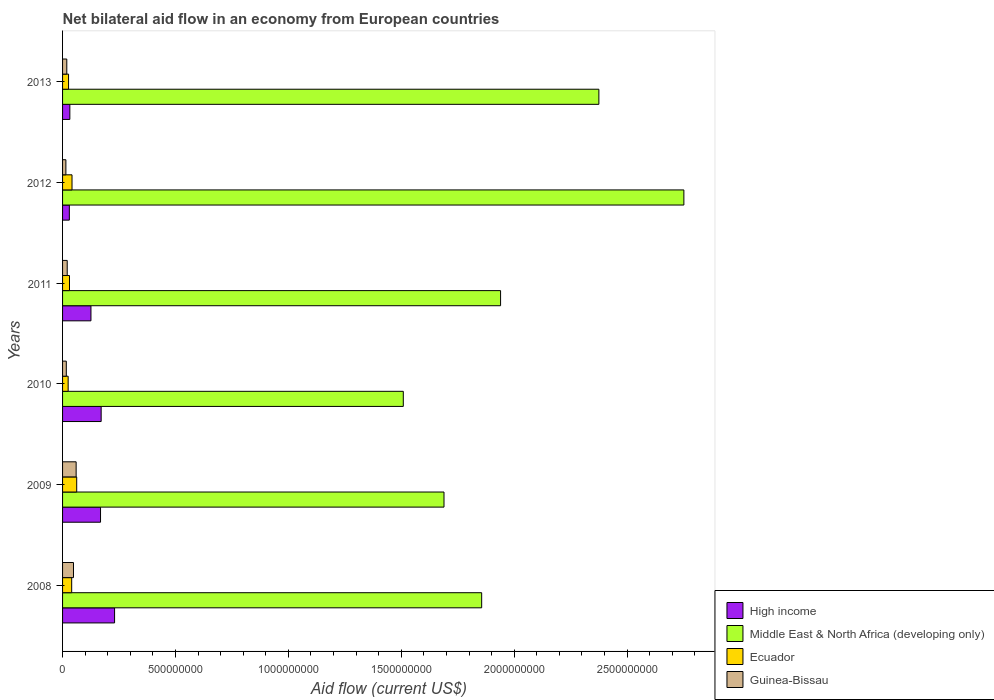How many different coloured bars are there?
Make the answer very short. 4. How many groups of bars are there?
Provide a short and direct response. 6. Are the number of bars per tick equal to the number of legend labels?
Give a very brief answer. Yes. How many bars are there on the 6th tick from the top?
Ensure brevity in your answer.  4. What is the label of the 1st group of bars from the top?
Give a very brief answer. 2013. What is the net bilateral aid flow in Middle East & North Africa (developing only) in 2012?
Provide a short and direct response. 2.75e+09. Across all years, what is the maximum net bilateral aid flow in Guinea-Bissau?
Keep it short and to the point. 6.01e+07. Across all years, what is the minimum net bilateral aid flow in Guinea-Bissau?
Your response must be concise. 1.47e+07. In which year was the net bilateral aid flow in Middle East & North Africa (developing only) minimum?
Offer a very short reply. 2010. What is the total net bilateral aid flow in Middle East & North Africa (developing only) in the graph?
Keep it short and to the point. 1.21e+1. What is the difference between the net bilateral aid flow in High income in 2010 and that in 2012?
Provide a short and direct response. 1.41e+08. What is the difference between the net bilateral aid flow in Middle East & North Africa (developing only) in 2010 and the net bilateral aid flow in High income in 2013?
Make the answer very short. 1.48e+09. What is the average net bilateral aid flow in Middle East & North Africa (developing only) per year?
Provide a succinct answer. 2.02e+09. In the year 2012, what is the difference between the net bilateral aid flow in High income and net bilateral aid flow in Ecuador?
Your response must be concise. -1.19e+07. What is the ratio of the net bilateral aid flow in Guinea-Bissau in 2008 to that in 2009?
Offer a very short reply. 0.8. Is the difference between the net bilateral aid flow in High income in 2011 and 2012 greater than the difference between the net bilateral aid flow in Ecuador in 2011 and 2012?
Ensure brevity in your answer.  Yes. What is the difference between the highest and the second highest net bilateral aid flow in High income?
Your response must be concise. 5.94e+07. What is the difference between the highest and the lowest net bilateral aid flow in Ecuador?
Keep it short and to the point. 3.79e+07. Is it the case that in every year, the sum of the net bilateral aid flow in High income and net bilateral aid flow in Middle East & North Africa (developing only) is greater than the sum of net bilateral aid flow in Ecuador and net bilateral aid flow in Guinea-Bissau?
Ensure brevity in your answer.  Yes. What does the 3rd bar from the top in 2009 represents?
Provide a short and direct response. Middle East & North Africa (developing only). What does the 1st bar from the bottom in 2012 represents?
Give a very brief answer. High income. Is it the case that in every year, the sum of the net bilateral aid flow in Guinea-Bissau and net bilateral aid flow in Middle East & North Africa (developing only) is greater than the net bilateral aid flow in High income?
Make the answer very short. Yes. How many bars are there?
Your answer should be compact. 24. Are the values on the major ticks of X-axis written in scientific E-notation?
Ensure brevity in your answer.  No. How many legend labels are there?
Provide a succinct answer. 4. What is the title of the graph?
Ensure brevity in your answer.  Net bilateral aid flow in an economy from European countries. Does "Syrian Arab Republic" appear as one of the legend labels in the graph?
Your answer should be compact. No. What is the label or title of the X-axis?
Your response must be concise. Aid flow (current US$). What is the Aid flow (current US$) in High income in 2008?
Offer a terse response. 2.30e+08. What is the Aid flow (current US$) of Middle East & North Africa (developing only) in 2008?
Your response must be concise. 1.86e+09. What is the Aid flow (current US$) of Ecuador in 2008?
Your answer should be very brief. 4.04e+07. What is the Aid flow (current US$) of Guinea-Bissau in 2008?
Ensure brevity in your answer.  4.84e+07. What is the Aid flow (current US$) of High income in 2009?
Offer a terse response. 1.68e+08. What is the Aid flow (current US$) of Middle East & North Africa (developing only) in 2009?
Offer a very short reply. 1.69e+09. What is the Aid flow (current US$) of Ecuador in 2009?
Offer a terse response. 6.26e+07. What is the Aid flow (current US$) in Guinea-Bissau in 2009?
Make the answer very short. 6.01e+07. What is the Aid flow (current US$) in High income in 2010?
Ensure brevity in your answer.  1.71e+08. What is the Aid flow (current US$) in Middle East & North Africa (developing only) in 2010?
Keep it short and to the point. 1.51e+09. What is the Aid flow (current US$) of Ecuador in 2010?
Provide a short and direct response. 2.47e+07. What is the Aid flow (current US$) in Guinea-Bissau in 2010?
Provide a succinct answer. 1.66e+07. What is the Aid flow (current US$) of High income in 2011?
Your answer should be compact. 1.26e+08. What is the Aid flow (current US$) in Middle East & North Africa (developing only) in 2011?
Provide a short and direct response. 1.94e+09. What is the Aid flow (current US$) in Ecuador in 2011?
Give a very brief answer. 3.07e+07. What is the Aid flow (current US$) of Guinea-Bissau in 2011?
Provide a short and direct response. 2.06e+07. What is the Aid flow (current US$) in High income in 2012?
Your response must be concise. 3.00e+07. What is the Aid flow (current US$) of Middle East & North Africa (developing only) in 2012?
Offer a very short reply. 2.75e+09. What is the Aid flow (current US$) of Ecuador in 2012?
Your answer should be very brief. 4.19e+07. What is the Aid flow (current US$) of Guinea-Bissau in 2012?
Your answer should be very brief. 1.47e+07. What is the Aid flow (current US$) in High income in 2013?
Ensure brevity in your answer.  3.22e+07. What is the Aid flow (current US$) in Middle East & North Africa (developing only) in 2013?
Your answer should be compact. 2.38e+09. What is the Aid flow (current US$) of Ecuador in 2013?
Your answer should be compact. 2.66e+07. What is the Aid flow (current US$) in Guinea-Bissau in 2013?
Your answer should be compact. 1.88e+07. Across all years, what is the maximum Aid flow (current US$) in High income?
Your answer should be compact. 2.30e+08. Across all years, what is the maximum Aid flow (current US$) of Middle East & North Africa (developing only)?
Ensure brevity in your answer.  2.75e+09. Across all years, what is the maximum Aid flow (current US$) of Ecuador?
Make the answer very short. 6.26e+07. Across all years, what is the maximum Aid flow (current US$) of Guinea-Bissau?
Offer a very short reply. 6.01e+07. Across all years, what is the minimum Aid flow (current US$) in High income?
Your answer should be compact. 3.00e+07. Across all years, what is the minimum Aid flow (current US$) in Middle East & North Africa (developing only)?
Your answer should be compact. 1.51e+09. Across all years, what is the minimum Aid flow (current US$) in Ecuador?
Provide a succinct answer. 2.47e+07. Across all years, what is the minimum Aid flow (current US$) in Guinea-Bissau?
Provide a short and direct response. 1.47e+07. What is the total Aid flow (current US$) of High income in the graph?
Provide a short and direct response. 7.57e+08. What is the total Aid flow (current US$) in Middle East & North Africa (developing only) in the graph?
Make the answer very short. 1.21e+1. What is the total Aid flow (current US$) in Ecuador in the graph?
Provide a succinct answer. 2.27e+08. What is the total Aid flow (current US$) in Guinea-Bissau in the graph?
Ensure brevity in your answer.  1.79e+08. What is the difference between the Aid flow (current US$) in High income in 2008 and that in 2009?
Provide a succinct answer. 6.22e+07. What is the difference between the Aid flow (current US$) in Middle East & North Africa (developing only) in 2008 and that in 2009?
Give a very brief answer. 1.67e+08. What is the difference between the Aid flow (current US$) of Ecuador in 2008 and that in 2009?
Give a very brief answer. -2.22e+07. What is the difference between the Aid flow (current US$) in Guinea-Bissau in 2008 and that in 2009?
Keep it short and to the point. -1.18e+07. What is the difference between the Aid flow (current US$) of High income in 2008 and that in 2010?
Make the answer very short. 5.94e+07. What is the difference between the Aid flow (current US$) in Middle East & North Africa (developing only) in 2008 and that in 2010?
Keep it short and to the point. 3.47e+08. What is the difference between the Aid flow (current US$) of Ecuador in 2008 and that in 2010?
Make the answer very short. 1.57e+07. What is the difference between the Aid flow (current US$) of Guinea-Bissau in 2008 and that in 2010?
Make the answer very short. 3.18e+07. What is the difference between the Aid flow (current US$) of High income in 2008 and that in 2011?
Provide a succinct answer. 1.05e+08. What is the difference between the Aid flow (current US$) of Middle East & North Africa (developing only) in 2008 and that in 2011?
Ensure brevity in your answer.  -8.38e+07. What is the difference between the Aid flow (current US$) in Ecuador in 2008 and that in 2011?
Ensure brevity in your answer.  9.73e+06. What is the difference between the Aid flow (current US$) of Guinea-Bissau in 2008 and that in 2011?
Make the answer very short. 2.78e+07. What is the difference between the Aid flow (current US$) of High income in 2008 and that in 2012?
Your answer should be compact. 2.00e+08. What is the difference between the Aid flow (current US$) of Middle East & North Africa (developing only) in 2008 and that in 2012?
Your answer should be very brief. -8.96e+08. What is the difference between the Aid flow (current US$) in Ecuador in 2008 and that in 2012?
Keep it short and to the point. -1.46e+06. What is the difference between the Aid flow (current US$) in Guinea-Bissau in 2008 and that in 2012?
Ensure brevity in your answer.  3.36e+07. What is the difference between the Aid flow (current US$) of High income in 2008 and that in 2013?
Ensure brevity in your answer.  1.98e+08. What is the difference between the Aid flow (current US$) in Middle East & North Africa (developing only) in 2008 and that in 2013?
Keep it short and to the point. -5.19e+08. What is the difference between the Aid flow (current US$) in Ecuador in 2008 and that in 2013?
Provide a short and direct response. 1.38e+07. What is the difference between the Aid flow (current US$) in Guinea-Bissau in 2008 and that in 2013?
Ensure brevity in your answer.  2.96e+07. What is the difference between the Aid flow (current US$) of High income in 2009 and that in 2010?
Your answer should be compact. -2.81e+06. What is the difference between the Aid flow (current US$) in Middle East & North Africa (developing only) in 2009 and that in 2010?
Your response must be concise. 1.80e+08. What is the difference between the Aid flow (current US$) of Ecuador in 2009 and that in 2010?
Give a very brief answer. 3.79e+07. What is the difference between the Aid flow (current US$) in Guinea-Bissau in 2009 and that in 2010?
Offer a terse response. 4.36e+07. What is the difference between the Aid flow (current US$) in High income in 2009 and that in 2011?
Keep it short and to the point. 4.24e+07. What is the difference between the Aid flow (current US$) of Middle East & North Africa (developing only) in 2009 and that in 2011?
Your answer should be compact. -2.51e+08. What is the difference between the Aid flow (current US$) in Ecuador in 2009 and that in 2011?
Your answer should be very brief. 3.20e+07. What is the difference between the Aid flow (current US$) of Guinea-Bissau in 2009 and that in 2011?
Offer a very short reply. 3.95e+07. What is the difference between the Aid flow (current US$) in High income in 2009 and that in 2012?
Make the answer very short. 1.38e+08. What is the difference between the Aid flow (current US$) of Middle East & North Africa (developing only) in 2009 and that in 2012?
Provide a short and direct response. -1.06e+09. What is the difference between the Aid flow (current US$) in Ecuador in 2009 and that in 2012?
Your answer should be very brief. 2.08e+07. What is the difference between the Aid flow (current US$) in Guinea-Bissau in 2009 and that in 2012?
Your answer should be compact. 4.54e+07. What is the difference between the Aid flow (current US$) of High income in 2009 and that in 2013?
Make the answer very short. 1.36e+08. What is the difference between the Aid flow (current US$) in Middle East & North Africa (developing only) in 2009 and that in 2013?
Give a very brief answer. -6.86e+08. What is the difference between the Aid flow (current US$) in Ecuador in 2009 and that in 2013?
Give a very brief answer. 3.60e+07. What is the difference between the Aid flow (current US$) of Guinea-Bissau in 2009 and that in 2013?
Your response must be concise. 4.14e+07. What is the difference between the Aid flow (current US$) of High income in 2010 and that in 2011?
Provide a short and direct response. 4.52e+07. What is the difference between the Aid flow (current US$) in Middle East & North Africa (developing only) in 2010 and that in 2011?
Your response must be concise. -4.31e+08. What is the difference between the Aid flow (current US$) of Ecuador in 2010 and that in 2011?
Provide a succinct answer. -5.94e+06. What is the difference between the Aid flow (current US$) of Guinea-Bissau in 2010 and that in 2011?
Give a very brief answer. -4.01e+06. What is the difference between the Aid flow (current US$) of High income in 2010 and that in 2012?
Keep it short and to the point. 1.41e+08. What is the difference between the Aid flow (current US$) of Middle East & North Africa (developing only) in 2010 and that in 2012?
Give a very brief answer. -1.24e+09. What is the difference between the Aid flow (current US$) of Ecuador in 2010 and that in 2012?
Make the answer very short. -1.71e+07. What is the difference between the Aid flow (current US$) in Guinea-Bissau in 2010 and that in 2012?
Give a very brief answer. 1.83e+06. What is the difference between the Aid flow (current US$) of High income in 2010 and that in 2013?
Ensure brevity in your answer.  1.39e+08. What is the difference between the Aid flow (current US$) of Middle East & North Africa (developing only) in 2010 and that in 2013?
Offer a very short reply. -8.66e+08. What is the difference between the Aid flow (current US$) of Ecuador in 2010 and that in 2013?
Offer a terse response. -1.85e+06. What is the difference between the Aid flow (current US$) of Guinea-Bissau in 2010 and that in 2013?
Your answer should be very brief. -2.18e+06. What is the difference between the Aid flow (current US$) in High income in 2011 and that in 2012?
Give a very brief answer. 9.57e+07. What is the difference between the Aid flow (current US$) in Middle East & North Africa (developing only) in 2011 and that in 2012?
Ensure brevity in your answer.  -8.12e+08. What is the difference between the Aid flow (current US$) of Ecuador in 2011 and that in 2012?
Your answer should be very brief. -1.12e+07. What is the difference between the Aid flow (current US$) of Guinea-Bissau in 2011 and that in 2012?
Provide a short and direct response. 5.84e+06. What is the difference between the Aid flow (current US$) of High income in 2011 and that in 2013?
Your answer should be compact. 9.34e+07. What is the difference between the Aid flow (current US$) in Middle East & North Africa (developing only) in 2011 and that in 2013?
Offer a very short reply. -4.35e+08. What is the difference between the Aid flow (current US$) of Ecuador in 2011 and that in 2013?
Give a very brief answer. 4.09e+06. What is the difference between the Aid flow (current US$) of Guinea-Bissau in 2011 and that in 2013?
Offer a terse response. 1.83e+06. What is the difference between the Aid flow (current US$) of High income in 2012 and that in 2013?
Provide a succinct answer. -2.25e+06. What is the difference between the Aid flow (current US$) in Middle East & North Africa (developing only) in 2012 and that in 2013?
Provide a succinct answer. 3.76e+08. What is the difference between the Aid flow (current US$) of Ecuador in 2012 and that in 2013?
Your answer should be compact. 1.53e+07. What is the difference between the Aid flow (current US$) in Guinea-Bissau in 2012 and that in 2013?
Your answer should be very brief. -4.01e+06. What is the difference between the Aid flow (current US$) in High income in 2008 and the Aid flow (current US$) in Middle East & North Africa (developing only) in 2009?
Your answer should be very brief. -1.46e+09. What is the difference between the Aid flow (current US$) of High income in 2008 and the Aid flow (current US$) of Ecuador in 2009?
Ensure brevity in your answer.  1.68e+08. What is the difference between the Aid flow (current US$) in High income in 2008 and the Aid flow (current US$) in Guinea-Bissau in 2009?
Keep it short and to the point. 1.70e+08. What is the difference between the Aid flow (current US$) of Middle East & North Africa (developing only) in 2008 and the Aid flow (current US$) of Ecuador in 2009?
Your response must be concise. 1.79e+09. What is the difference between the Aid flow (current US$) in Middle East & North Africa (developing only) in 2008 and the Aid flow (current US$) in Guinea-Bissau in 2009?
Provide a succinct answer. 1.80e+09. What is the difference between the Aid flow (current US$) in Ecuador in 2008 and the Aid flow (current US$) in Guinea-Bissau in 2009?
Provide a succinct answer. -1.97e+07. What is the difference between the Aid flow (current US$) in High income in 2008 and the Aid flow (current US$) in Middle East & North Africa (developing only) in 2010?
Your answer should be compact. -1.28e+09. What is the difference between the Aid flow (current US$) in High income in 2008 and the Aid flow (current US$) in Ecuador in 2010?
Provide a short and direct response. 2.06e+08. What is the difference between the Aid flow (current US$) in High income in 2008 and the Aid flow (current US$) in Guinea-Bissau in 2010?
Offer a very short reply. 2.14e+08. What is the difference between the Aid flow (current US$) in Middle East & North Africa (developing only) in 2008 and the Aid flow (current US$) in Ecuador in 2010?
Provide a short and direct response. 1.83e+09. What is the difference between the Aid flow (current US$) of Middle East & North Africa (developing only) in 2008 and the Aid flow (current US$) of Guinea-Bissau in 2010?
Ensure brevity in your answer.  1.84e+09. What is the difference between the Aid flow (current US$) of Ecuador in 2008 and the Aid flow (current US$) of Guinea-Bissau in 2010?
Your answer should be compact. 2.38e+07. What is the difference between the Aid flow (current US$) in High income in 2008 and the Aid flow (current US$) in Middle East & North Africa (developing only) in 2011?
Keep it short and to the point. -1.71e+09. What is the difference between the Aid flow (current US$) in High income in 2008 and the Aid flow (current US$) in Ecuador in 2011?
Offer a very short reply. 2.00e+08. What is the difference between the Aid flow (current US$) of High income in 2008 and the Aid flow (current US$) of Guinea-Bissau in 2011?
Give a very brief answer. 2.10e+08. What is the difference between the Aid flow (current US$) in Middle East & North Africa (developing only) in 2008 and the Aid flow (current US$) in Ecuador in 2011?
Keep it short and to the point. 1.83e+09. What is the difference between the Aid flow (current US$) of Middle East & North Africa (developing only) in 2008 and the Aid flow (current US$) of Guinea-Bissau in 2011?
Your answer should be very brief. 1.84e+09. What is the difference between the Aid flow (current US$) in Ecuador in 2008 and the Aid flow (current US$) in Guinea-Bissau in 2011?
Your answer should be very brief. 1.98e+07. What is the difference between the Aid flow (current US$) of High income in 2008 and the Aid flow (current US$) of Middle East & North Africa (developing only) in 2012?
Ensure brevity in your answer.  -2.52e+09. What is the difference between the Aid flow (current US$) in High income in 2008 and the Aid flow (current US$) in Ecuador in 2012?
Offer a very short reply. 1.88e+08. What is the difference between the Aid flow (current US$) in High income in 2008 and the Aid flow (current US$) in Guinea-Bissau in 2012?
Your response must be concise. 2.16e+08. What is the difference between the Aid flow (current US$) in Middle East & North Africa (developing only) in 2008 and the Aid flow (current US$) in Ecuador in 2012?
Give a very brief answer. 1.81e+09. What is the difference between the Aid flow (current US$) of Middle East & North Africa (developing only) in 2008 and the Aid flow (current US$) of Guinea-Bissau in 2012?
Ensure brevity in your answer.  1.84e+09. What is the difference between the Aid flow (current US$) of Ecuador in 2008 and the Aid flow (current US$) of Guinea-Bissau in 2012?
Give a very brief answer. 2.57e+07. What is the difference between the Aid flow (current US$) in High income in 2008 and the Aid flow (current US$) in Middle East & North Africa (developing only) in 2013?
Offer a very short reply. -2.14e+09. What is the difference between the Aid flow (current US$) of High income in 2008 and the Aid flow (current US$) of Ecuador in 2013?
Your answer should be very brief. 2.04e+08. What is the difference between the Aid flow (current US$) in High income in 2008 and the Aid flow (current US$) in Guinea-Bissau in 2013?
Ensure brevity in your answer.  2.12e+08. What is the difference between the Aid flow (current US$) of Middle East & North Africa (developing only) in 2008 and the Aid flow (current US$) of Ecuador in 2013?
Offer a very short reply. 1.83e+09. What is the difference between the Aid flow (current US$) of Middle East & North Africa (developing only) in 2008 and the Aid flow (current US$) of Guinea-Bissau in 2013?
Give a very brief answer. 1.84e+09. What is the difference between the Aid flow (current US$) of Ecuador in 2008 and the Aid flow (current US$) of Guinea-Bissau in 2013?
Ensure brevity in your answer.  2.17e+07. What is the difference between the Aid flow (current US$) of High income in 2009 and the Aid flow (current US$) of Middle East & North Africa (developing only) in 2010?
Your answer should be very brief. -1.34e+09. What is the difference between the Aid flow (current US$) of High income in 2009 and the Aid flow (current US$) of Ecuador in 2010?
Your response must be concise. 1.43e+08. What is the difference between the Aid flow (current US$) of High income in 2009 and the Aid flow (current US$) of Guinea-Bissau in 2010?
Provide a succinct answer. 1.52e+08. What is the difference between the Aid flow (current US$) of Middle East & North Africa (developing only) in 2009 and the Aid flow (current US$) of Ecuador in 2010?
Your response must be concise. 1.66e+09. What is the difference between the Aid flow (current US$) of Middle East & North Africa (developing only) in 2009 and the Aid flow (current US$) of Guinea-Bissau in 2010?
Your answer should be very brief. 1.67e+09. What is the difference between the Aid flow (current US$) of Ecuador in 2009 and the Aid flow (current US$) of Guinea-Bissau in 2010?
Your response must be concise. 4.61e+07. What is the difference between the Aid flow (current US$) of High income in 2009 and the Aid flow (current US$) of Middle East & North Africa (developing only) in 2011?
Provide a succinct answer. -1.77e+09. What is the difference between the Aid flow (current US$) of High income in 2009 and the Aid flow (current US$) of Ecuador in 2011?
Offer a very short reply. 1.37e+08. What is the difference between the Aid flow (current US$) in High income in 2009 and the Aid flow (current US$) in Guinea-Bissau in 2011?
Provide a succinct answer. 1.48e+08. What is the difference between the Aid flow (current US$) in Middle East & North Africa (developing only) in 2009 and the Aid flow (current US$) in Ecuador in 2011?
Offer a terse response. 1.66e+09. What is the difference between the Aid flow (current US$) in Middle East & North Africa (developing only) in 2009 and the Aid flow (current US$) in Guinea-Bissau in 2011?
Provide a short and direct response. 1.67e+09. What is the difference between the Aid flow (current US$) in Ecuador in 2009 and the Aid flow (current US$) in Guinea-Bissau in 2011?
Your answer should be compact. 4.20e+07. What is the difference between the Aid flow (current US$) in High income in 2009 and the Aid flow (current US$) in Middle East & North Africa (developing only) in 2012?
Ensure brevity in your answer.  -2.58e+09. What is the difference between the Aid flow (current US$) of High income in 2009 and the Aid flow (current US$) of Ecuador in 2012?
Your answer should be compact. 1.26e+08. What is the difference between the Aid flow (current US$) in High income in 2009 and the Aid flow (current US$) in Guinea-Bissau in 2012?
Provide a succinct answer. 1.53e+08. What is the difference between the Aid flow (current US$) of Middle East & North Africa (developing only) in 2009 and the Aid flow (current US$) of Ecuador in 2012?
Your answer should be very brief. 1.65e+09. What is the difference between the Aid flow (current US$) of Middle East & North Africa (developing only) in 2009 and the Aid flow (current US$) of Guinea-Bissau in 2012?
Give a very brief answer. 1.67e+09. What is the difference between the Aid flow (current US$) of Ecuador in 2009 and the Aid flow (current US$) of Guinea-Bissau in 2012?
Make the answer very short. 4.79e+07. What is the difference between the Aid flow (current US$) of High income in 2009 and the Aid flow (current US$) of Middle East & North Africa (developing only) in 2013?
Keep it short and to the point. -2.21e+09. What is the difference between the Aid flow (current US$) of High income in 2009 and the Aid flow (current US$) of Ecuador in 2013?
Your answer should be very brief. 1.42e+08. What is the difference between the Aid flow (current US$) of High income in 2009 and the Aid flow (current US$) of Guinea-Bissau in 2013?
Offer a very short reply. 1.49e+08. What is the difference between the Aid flow (current US$) in Middle East & North Africa (developing only) in 2009 and the Aid flow (current US$) in Ecuador in 2013?
Ensure brevity in your answer.  1.66e+09. What is the difference between the Aid flow (current US$) of Middle East & North Africa (developing only) in 2009 and the Aid flow (current US$) of Guinea-Bissau in 2013?
Provide a succinct answer. 1.67e+09. What is the difference between the Aid flow (current US$) of Ecuador in 2009 and the Aid flow (current US$) of Guinea-Bissau in 2013?
Make the answer very short. 4.39e+07. What is the difference between the Aid flow (current US$) of High income in 2010 and the Aid flow (current US$) of Middle East & North Africa (developing only) in 2011?
Your answer should be very brief. -1.77e+09. What is the difference between the Aid flow (current US$) in High income in 2010 and the Aid flow (current US$) in Ecuador in 2011?
Offer a very short reply. 1.40e+08. What is the difference between the Aid flow (current US$) in High income in 2010 and the Aid flow (current US$) in Guinea-Bissau in 2011?
Provide a succinct answer. 1.50e+08. What is the difference between the Aid flow (current US$) in Middle East & North Africa (developing only) in 2010 and the Aid flow (current US$) in Ecuador in 2011?
Your response must be concise. 1.48e+09. What is the difference between the Aid flow (current US$) in Middle East & North Africa (developing only) in 2010 and the Aid flow (current US$) in Guinea-Bissau in 2011?
Your answer should be very brief. 1.49e+09. What is the difference between the Aid flow (current US$) of Ecuador in 2010 and the Aid flow (current US$) of Guinea-Bissau in 2011?
Offer a very short reply. 4.16e+06. What is the difference between the Aid flow (current US$) of High income in 2010 and the Aid flow (current US$) of Middle East & North Africa (developing only) in 2012?
Your answer should be compact. -2.58e+09. What is the difference between the Aid flow (current US$) of High income in 2010 and the Aid flow (current US$) of Ecuador in 2012?
Ensure brevity in your answer.  1.29e+08. What is the difference between the Aid flow (current US$) of High income in 2010 and the Aid flow (current US$) of Guinea-Bissau in 2012?
Provide a succinct answer. 1.56e+08. What is the difference between the Aid flow (current US$) of Middle East & North Africa (developing only) in 2010 and the Aid flow (current US$) of Ecuador in 2012?
Provide a succinct answer. 1.47e+09. What is the difference between the Aid flow (current US$) in Middle East & North Africa (developing only) in 2010 and the Aid flow (current US$) in Guinea-Bissau in 2012?
Your answer should be very brief. 1.49e+09. What is the difference between the Aid flow (current US$) in High income in 2010 and the Aid flow (current US$) in Middle East & North Africa (developing only) in 2013?
Your response must be concise. -2.20e+09. What is the difference between the Aid flow (current US$) in High income in 2010 and the Aid flow (current US$) in Ecuador in 2013?
Provide a short and direct response. 1.44e+08. What is the difference between the Aid flow (current US$) in High income in 2010 and the Aid flow (current US$) in Guinea-Bissau in 2013?
Give a very brief answer. 1.52e+08. What is the difference between the Aid flow (current US$) in Middle East & North Africa (developing only) in 2010 and the Aid flow (current US$) in Ecuador in 2013?
Provide a short and direct response. 1.48e+09. What is the difference between the Aid flow (current US$) in Middle East & North Africa (developing only) in 2010 and the Aid flow (current US$) in Guinea-Bissau in 2013?
Offer a terse response. 1.49e+09. What is the difference between the Aid flow (current US$) in Ecuador in 2010 and the Aid flow (current US$) in Guinea-Bissau in 2013?
Your response must be concise. 5.99e+06. What is the difference between the Aid flow (current US$) of High income in 2011 and the Aid flow (current US$) of Middle East & North Africa (developing only) in 2012?
Your answer should be compact. -2.63e+09. What is the difference between the Aid flow (current US$) in High income in 2011 and the Aid flow (current US$) in Ecuador in 2012?
Ensure brevity in your answer.  8.38e+07. What is the difference between the Aid flow (current US$) of High income in 2011 and the Aid flow (current US$) of Guinea-Bissau in 2012?
Keep it short and to the point. 1.11e+08. What is the difference between the Aid flow (current US$) in Middle East & North Africa (developing only) in 2011 and the Aid flow (current US$) in Ecuador in 2012?
Your response must be concise. 1.90e+09. What is the difference between the Aid flow (current US$) of Middle East & North Africa (developing only) in 2011 and the Aid flow (current US$) of Guinea-Bissau in 2012?
Provide a succinct answer. 1.93e+09. What is the difference between the Aid flow (current US$) of Ecuador in 2011 and the Aid flow (current US$) of Guinea-Bissau in 2012?
Provide a short and direct response. 1.59e+07. What is the difference between the Aid flow (current US$) of High income in 2011 and the Aid flow (current US$) of Middle East & North Africa (developing only) in 2013?
Your answer should be compact. -2.25e+09. What is the difference between the Aid flow (current US$) in High income in 2011 and the Aid flow (current US$) in Ecuador in 2013?
Make the answer very short. 9.91e+07. What is the difference between the Aid flow (current US$) in High income in 2011 and the Aid flow (current US$) in Guinea-Bissau in 2013?
Your answer should be compact. 1.07e+08. What is the difference between the Aid flow (current US$) in Middle East & North Africa (developing only) in 2011 and the Aid flow (current US$) in Ecuador in 2013?
Keep it short and to the point. 1.91e+09. What is the difference between the Aid flow (current US$) of Middle East & North Africa (developing only) in 2011 and the Aid flow (current US$) of Guinea-Bissau in 2013?
Your response must be concise. 1.92e+09. What is the difference between the Aid flow (current US$) of Ecuador in 2011 and the Aid flow (current US$) of Guinea-Bissau in 2013?
Your answer should be very brief. 1.19e+07. What is the difference between the Aid flow (current US$) in High income in 2012 and the Aid flow (current US$) in Middle East & North Africa (developing only) in 2013?
Provide a short and direct response. -2.35e+09. What is the difference between the Aid flow (current US$) in High income in 2012 and the Aid flow (current US$) in Ecuador in 2013?
Your answer should be compact. 3.41e+06. What is the difference between the Aid flow (current US$) of High income in 2012 and the Aid flow (current US$) of Guinea-Bissau in 2013?
Provide a succinct answer. 1.12e+07. What is the difference between the Aid flow (current US$) of Middle East & North Africa (developing only) in 2012 and the Aid flow (current US$) of Ecuador in 2013?
Keep it short and to the point. 2.72e+09. What is the difference between the Aid flow (current US$) of Middle East & North Africa (developing only) in 2012 and the Aid flow (current US$) of Guinea-Bissau in 2013?
Ensure brevity in your answer.  2.73e+09. What is the difference between the Aid flow (current US$) of Ecuador in 2012 and the Aid flow (current US$) of Guinea-Bissau in 2013?
Offer a very short reply. 2.31e+07. What is the average Aid flow (current US$) in High income per year?
Keep it short and to the point. 1.26e+08. What is the average Aid flow (current US$) in Middle East & North Africa (developing only) per year?
Your response must be concise. 2.02e+09. What is the average Aid flow (current US$) of Ecuador per year?
Provide a short and direct response. 3.78e+07. What is the average Aid flow (current US$) in Guinea-Bissau per year?
Your response must be concise. 2.99e+07. In the year 2008, what is the difference between the Aid flow (current US$) of High income and Aid flow (current US$) of Middle East & North Africa (developing only)?
Your response must be concise. -1.63e+09. In the year 2008, what is the difference between the Aid flow (current US$) of High income and Aid flow (current US$) of Ecuador?
Offer a terse response. 1.90e+08. In the year 2008, what is the difference between the Aid flow (current US$) of High income and Aid flow (current US$) of Guinea-Bissau?
Your answer should be compact. 1.82e+08. In the year 2008, what is the difference between the Aid flow (current US$) in Middle East & North Africa (developing only) and Aid flow (current US$) in Ecuador?
Your answer should be very brief. 1.82e+09. In the year 2008, what is the difference between the Aid flow (current US$) of Middle East & North Africa (developing only) and Aid flow (current US$) of Guinea-Bissau?
Give a very brief answer. 1.81e+09. In the year 2008, what is the difference between the Aid flow (current US$) in Ecuador and Aid flow (current US$) in Guinea-Bissau?
Your answer should be compact. -7.96e+06. In the year 2009, what is the difference between the Aid flow (current US$) in High income and Aid flow (current US$) in Middle East & North Africa (developing only)?
Ensure brevity in your answer.  -1.52e+09. In the year 2009, what is the difference between the Aid flow (current US$) in High income and Aid flow (current US$) in Ecuador?
Make the answer very short. 1.05e+08. In the year 2009, what is the difference between the Aid flow (current US$) in High income and Aid flow (current US$) in Guinea-Bissau?
Your answer should be very brief. 1.08e+08. In the year 2009, what is the difference between the Aid flow (current US$) of Middle East & North Africa (developing only) and Aid flow (current US$) of Ecuador?
Provide a short and direct response. 1.63e+09. In the year 2009, what is the difference between the Aid flow (current US$) in Middle East & North Africa (developing only) and Aid flow (current US$) in Guinea-Bissau?
Your response must be concise. 1.63e+09. In the year 2009, what is the difference between the Aid flow (current US$) in Ecuador and Aid flow (current US$) in Guinea-Bissau?
Provide a short and direct response. 2.51e+06. In the year 2010, what is the difference between the Aid flow (current US$) of High income and Aid flow (current US$) of Middle East & North Africa (developing only)?
Provide a succinct answer. -1.34e+09. In the year 2010, what is the difference between the Aid flow (current US$) of High income and Aid flow (current US$) of Ecuador?
Keep it short and to the point. 1.46e+08. In the year 2010, what is the difference between the Aid flow (current US$) of High income and Aid flow (current US$) of Guinea-Bissau?
Provide a succinct answer. 1.54e+08. In the year 2010, what is the difference between the Aid flow (current US$) in Middle East & North Africa (developing only) and Aid flow (current US$) in Ecuador?
Your response must be concise. 1.48e+09. In the year 2010, what is the difference between the Aid flow (current US$) in Middle East & North Africa (developing only) and Aid flow (current US$) in Guinea-Bissau?
Offer a very short reply. 1.49e+09. In the year 2010, what is the difference between the Aid flow (current US$) of Ecuador and Aid flow (current US$) of Guinea-Bissau?
Your answer should be very brief. 8.17e+06. In the year 2011, what is the difference between the Aid flow (current US$) in High income and Aid flow (current US$) in Middle East & North Africa (developing only)?
Provide a short and direct response. -1.81e+09. In the year 2011, what is the difference between the Aid flow (current US$) of High income and Aid flow (current US$) of Ecuador?
Give a very brief answer. 9.50e+07. In the year 2011, what is the difference between the Aid flow (current US$) of High income and Aid flow (current US$) of Guinea-Bissau?
Provide a succinct answer. 1.05e+08. In the year 2011, what is the difference between the Aid flow (current US$) of Middle East & North Africa (developing only) and Aid flow (current US$) of Ecuador?
Provide a short and direct response. 1.91e+09. In the year 2011, what is the difference between the Aid flow (current US$) of Middle East & North Africa (developing only) and Aid flow (current US$) of Guinea-Bissau?
Ensure brevity in your answer.  1.92e+09. In the year 2011, what is the difference between the Aid flow (current US$) in Ecuador and Aid flow (current US$) in Guinea-Bissau?
Ensure brevity in your answer.  1.01e+07. In the year 2012, what is the difference between the Aid flow (current US$) of High income and Aid flow (current US$) of Middle East & North Africa (developing only)?
Your response must be concise. -2.72e+09. In the year 2012, what is the difference between the Aid flow (current US$) in High income and Aid flow (current US$) in Ecuador?
Provide a succinct answer. -1.19e+07. In the year 2012, what is the difference between the Aid flow (current US$) of High income and Aid flow (current US$) of Guinea-Bissau?
Your answer should be very brief. 1.53e+07. In the year 2012, what is the difference between the Aid flow (current US$) of Middle East & North Africa (developing only) and Aid flow (current US$) of Ecuador?
Your response must be concise. 2.71e+09. In the year 2012, what is the difference between the Aid flow (current US$) of Middle East & North Africa (developing only) and Aid flow (current US$) of Guinea-Bissau?
Provide a short and direct response. 2.74e+09. In the year 2012, what is the difference between the Aid flow (current US$) in Ecuador and Aid flow (current US$) in Guinea-Bissau?
Keep it short and to the point. 2.71e+07. In the year 2013, what is the difference between the Aid flow (current US$) of High income and Aid flow (current US$) of Middle East & North Africa (developing only)?
Give a very brief answer. -2.34e+09. In the year 2013, what is the difference between the Aid flow (current US$) in High income and Aid flow (current US$) in Ecuador?
Provide a succinct answer. 5.66e+06. In the year 2013, what is the difference between the Aid flow (current US$) in High income and Aid flow (current US$) in Guinea-Bissau?
Provide a succinct answer. 1.35e+07. In the year 2013, what is the difference between the Aid flow (current US$) of Middle East & North Africa (developing only) and Aid flow (current US$) of Ecuador?
Provide a short and direct response. 2.35e+09. In the year 2013, what is the difference between the Aid flow (current US$) of Middle East & North Africa (developing only) and Aid flow (current US$) of Guinea-Bissau?
Your response must be concise. 2.36e+09. In the year 2013, what is the difference between the Aid flow (current US$) of Ecuador and Aid flow (current US$) of Guinea-Bissau?
Give a very brief answer. 7.84e+06. What is the ratio of the Aid flow (current US$) in High income in 2008 to that in 2009?
Offer a very short reply. 1.37. What is the ratio of the Aid flow (current US$) of Middle East & North Africa (developing only) in 2008 to that in 2009?
Provide a short and direct response. 1.1. What is the ratio of the Aid flow (current US$) in Ecuador in 2008 to that in 2009?
Provide a short and direct response. 0.65. What is the ratio of the Aid flow (current US$) in Guinea-Bissau in 2008 to that in 2009?
Offer a very short reply. 0.8. What is the ratio of the Aid flow (current US$) in High income in 2008 to that in 2010?
Your response must be concise. 1.35. What is the ratio of the Aid flow (current US$) in Middle East & North Africa (developing only) in 2008 to that in 2010?
Provide a short and direct response. 1.23. What is the ratio of the Aid flow (current US$) in Ecuador in 2008 to that in 2010?
Offer a terse response. 1.63. What is the ratio of the Aid flow (current US$) of Guinea-Bissau in 2008 to that in 2010?
Ensure brevity in your answer.  2.92. What is the ratio of the Aid flow (current US$) in High income in 2008 to that in 2011?
Make the answer very short. 1.83. What is the ratio of the Aid flow (current US$) of Middle East & North Africa (developing only) in 2008 to that in 2011?
Your response must be concise. 0.96. What is the ratio of the Aid flow (current US$) of Ecuador in 2008 to that in 2011?
Keep it short and to the point. 1.32. What is the ratio of the Aid flow (current US$) of Guinea-Bissau in 2008 to that in 2011?
Provide a succinct answer. 2.35. What is the ratio of the Aid flow (current US$) in High income in 2008 to that in 2012?
Offer a very short reply. 7.68. What is the ratio of the Aid flow (current US$) in Middle East & North Africa (developing only) in 2008 to that in 2012?
Offer a terse response. 0.67. What is the ratio of the Aid flow (current US$) in Ecuador in 2008 to that in 2012?
Keep it short and to the point. 0.97. What is the ratio of the Aid flow (current US$) in Guinea-Bissau in 2008 to that in 2012?
Make the answer very short. 3.28. What is the ratio of the Aid flow (current US$) of High income in 2008 to that in 2013?
Provide a succinct answer. 7.14. What is the ratio of the Aid flow (current US$) of Middle East & North Africa (developing only) in 2008 to that in 2013?
Offer a very short reply. 0.78. What is the ratio of the Aid flow (current US$) in Ecuador in 2008 to that in 2013?
Your answer should be compact. 1.52. What is the ratio of the Aid flow (current US$) in Guinea-Bissau in 2008 to that in 2013?
Your response must be concise. 2.58. What is the ratio of the Aid flow (current US$) in High income in 2009 to that in 2010?
Provide a succinct answer. 0.98. What is the ratio of the Aid flow (current US$) of Middle East & North Africa (developing only) in 2009 to that in 2010?
Provide a succinct answer. 1.12. What is the ratio of the Aid flow (current US$) in Ecuador in 2009 to that in 2010?
Give a very brief answer. 2.53. What is the ratio of the Aid flow (current US$) of Guinea-Bissau in 2009 to that in 2010?
Give a very brief answer. 3.63. What is the ratio of the Aid flow (current US$) of High income in 2009 to that in 2011?
Give a very brief answer. 1.34. What is the ratio of the Aid flow (current US$) in Middle East & North Africa (developing only) in 2009 to that in 2011?
Keep it short and to the point. 0.87. What is the ratio of the Aid flow (current US$) in Ecuador in 2009 to that in 2011?
Provide a short and direct response. 2.04. What is the ratio of the Aid flow (current US$) in Guinea-Bissau in 2009 to that in 2011?
Offer a terse response. 2.92. What is the ratio of the Aid flow (current US$) in High income in 2009 to that in 2012?
Your answer should be very brief. 5.6. What is the ratio of the Aid flow (current US$) of Middle East & North Africa (developing only) in 2009 to that in 2012?
Your response must be concise. 0.61. What is the ratio of the Aid flow (current US$) in Ecuador in 2009 to that in 2012?
Your answer should be compact. 1.5. What is the ratio of the Aid flow (current US$) of Guinea-Bissau in 2009 to that in 2012?
Give a very brief answer. 4.08. What is the ratio of the Aid flow (current US$) in High income in 2009 to that in 2013?
Make the answer very short. 5.21. What is the ratio of the Aid flow (current US$) in Middle East & North Africa (developing only) in 2009 to that in 2013?
Your answer should be compact. 0.71. What is the ratio of the Aid flow (current US$) in Ecuador in 2009 to that in 2013?
Give a very brief answer. 2.36. What is the ratio of the Aid flow (current US$) in Guinea-Bissau in 2009 to that in 2013?
Keep it short and to the point. 3.21. What is the ratio of the Aid flow (current US$) in High income in 2010 to that in 2011?
Offer a terse response. 1.36. What is the ratio of the Aid flow (current US$) of Middle East & North Africa (developing only) in 2010 to that in 2011?
Ensure brevity in your answer.  0.78. What is the ratio of the Aid flow (current US$) in Ecuador in 2010 to that in 2011?
Provide a short and direct response. 0.81. What is the ratio of the Aid flow (current US$) of Guinea-Bissau in 2010 to that in 2011?
Your answer should be compact. 0.81. What is the ratio of the Aid flow (current US$) of High income in 2010 to that in 2012?
Provide a short and direct response. 5.7. What is the ratio of the Aid flow (current US$) of Middle East & North Africa (developing only) in 2010 to that in 2012?
Ensure brevity in your answer.  0.55. What is the ratio of the Aid flow (current US$) of Ecuador in 2010 to that in 2012?
Give a very brief answer. 0.59. What is the ratio of the Aid flow (current US$) in Guinea-Bissau in 2010 to that in 2012?
Provide a short and direct response. 1.12. What is the ratio of the Aid flow (current US$) in High income in 2010 to that in 2013?
Keep it short and to the point. 5.3. What is the ratio of the Aid flow (current US$) in Middle East & North Africa (developing only) in 2010 to that in 2013?
Provide a short and direct response. 0.64. What is the ratio of the Aid flow (current US$) in Ecuador in 2010 to that in 2013?
Make the answer very short. 0.93. What is the ratio of the Aid flow (current US$) in Guinea-Bissau in 2010 to that in 2013?
Make the answer very short. 0.88. What is the ratio of the Aid flow (current US$) of High income in 2011 to that in 2012?
Keep it short and to the point. 4.19. What is the ratio of the Aid flow (current US$) in Middle East & North Africa (developing only) in 2011 to that in 2012?
Your response must be concise. 0.7. What is the ratio of the Aid flow (current US$) of Ecuador in 2011 to that in 2012?
Provide a short and direct response. 0.73. What is the ratio of the Aid flow (current US$) of Guinea-Bissau in 2011 to that in 2012?
Offer a very short reply. 1.4. What is the ratio of the Aid flow (current US$) in High income in 2011 to that in 2013?
Your answer should be compact. 3.9. What is the ratio of the Aid flow (current US$) in Middle East & North Africa (developing only) in 2011 to that in 2013?
Your response must be concise. 0.82. What is the ratio of the Aid flow (current US$) of Ecuador in 2011 to that in 2013?
Provide a succinct answer. 1.15. What is the ratio of the Aid flow (current US$) in Guinea-Bissau in 2011 to that in 2013?
Provide a short and direct response. 1.1. What is the ratio of the Aid flow (current US$) in High income in 2012 to that in 2013?
Provide a succinct answer. 0.93. What is the ratio of the Aid flow (current US$) of Middle East & North Africa (developing only) in 2012 to that in 2013?
Your answer should be very brief. 1.16. What is the ratio of the Aid flow (current US$) of Ecuador in 2012 to that in 2013?
Provide a succinct answer. 1.57. What is the ratio of the Aid flow (current US$) of Guinea-Bissau in 2012 to that in 2013?
Offer a terse response. 0.79. What is the difference between the highest and the second highest Aid flow (current US$) of High income?
Give a very brief answer. 5.94e+07. What is the difference between the highest and the second highest Aid flow (current US$) of Middle East & North Africa (developing only)?
Give a very brief answer. 3.76e+08. What is the difference between the highest and the second highest Aid flow (current US$) of Ecuador?
Offer a very short reply. 2.08e+07. What is the difference between the highest and the second highest Aid flow (current US$) in Guinea-Bissau?
Your answer should be compact. 1.18e+07. What is the difference between the highest and the lowest Aid flow (current US$) of High income?
Ensure brevity in your answer.  2.00e+08. What is the difference between the highest and the lowest Aid flow (current US$) in Middle East & North Africa (developing only)?
Keep it short and to the point. 1.24e+09. What is the difference between the highest and the lowest Aid flow (current US$) of Ecuador?
Give a very brief answer. 3.79e+07. What is the difference between the highest and the lowest Aid flow (current US$) in Guinea-Bissau?
Keep it short and to the point. 4.54e+07. 